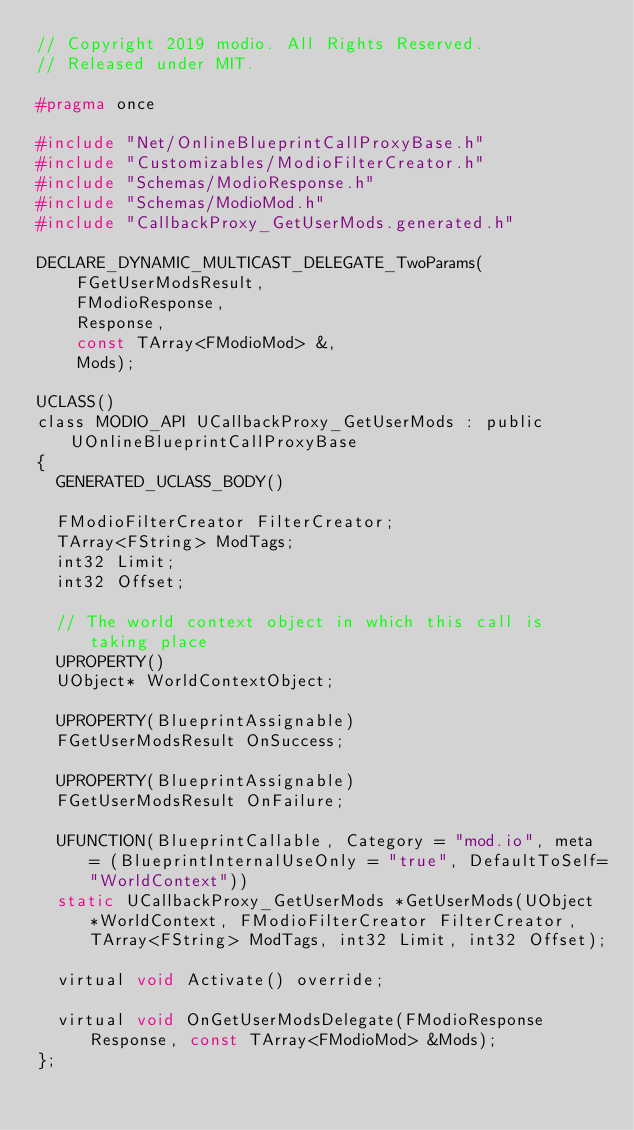<code> <loc_0><loc_0><loc_500><loc_500><_C_>// Copyright 2019 modio. All Rights Reserved.
// Released under MIT.

#pragma once

#include "Net/OnlineBlueprintCallProxyBase.h"
#include "Customizables/ModioFilterCreator.h"
#include "Schemas/ModioResponse.h"
#include "Schemas/ModioMod.h"
#include "CallbackProxy_GetUserMods.generated.h"

DECLARE_DYNAMIC_MULTICAST_DELEGATE_TwoParams(
    FGetUserModsResult,
    FModioResponse,
    Response,
    const TArray<FModioMod> &,
    Mods);

UCLASS()
class MODIO_API UCallbackProxy_GetUserMods : public UOnlineBlueprintCallProxyBase
{
  GENERATED_UCLASS_BODY()

  FModioFilterCreator FilterCreator;
  TArray<FString> ModTags;
  int32 Limit;
  int32 Offset;

  // The world context object in which this call is taking place
  UPROPERTY()
  UObject* WorldContextObject;

  UPROPERTY(BlueprintAssignable)
  FGetUserModsResult OnSuccess;

  UPROPERTY(BlueprintAssignable)
  FGetUserModsResult OnFailure;

  UFUNCTION(BlueprintCallable, Category = "mod.io", meta = (BlueprintInternalUseOnly = "true", DefaultToSelf="WorldContext"))
  static UCallbackProxy_GetUserMods *GetUserMods(UObject *WorldContext, FModioFilterCreator FilterCreator, TArray<FString> ModTags, int32 Limit, int32 Offset);

  virtual void Activate() override;

  virtual void OnGetUserModsDelegate(FModioResponse Response, const TArray<FModioMod> &Mods);
};</code> 